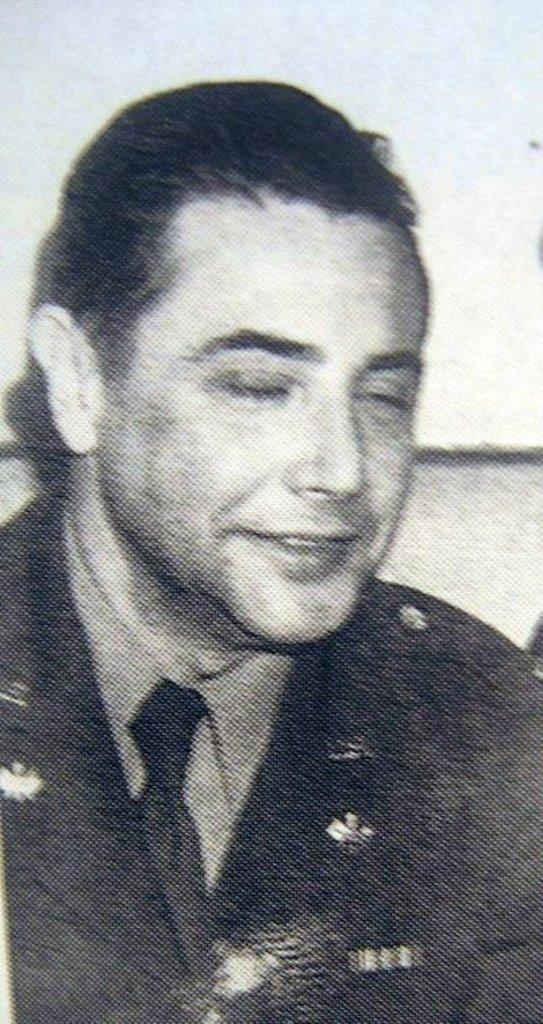What is the color scheme of the image? The image is black and white. Can you describe the person in the image? The person in the image is wearing a blazer, a tie, and a shirt. What is the person's facial expression in the image? The person is smiling with their eyes closed. What type of tramp can be seen in the image? There is no tramp present in the image. What kind of test is the person taking in the image? There is no test being taken in the image. 